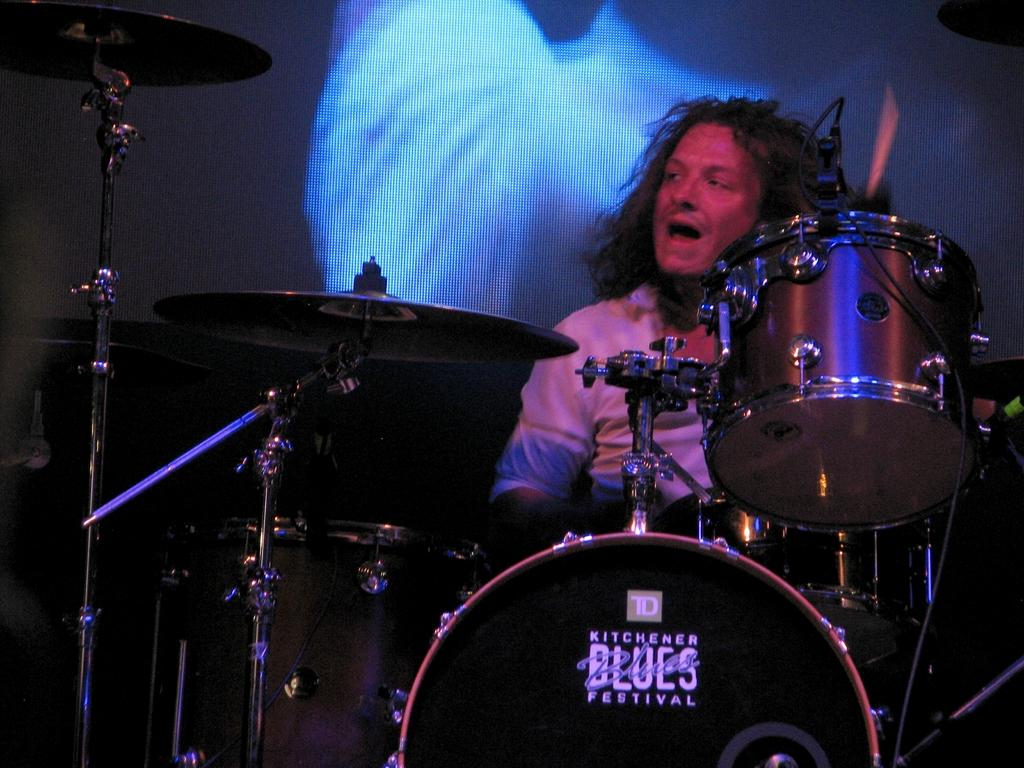Who or what is the main subject in the image? There is a person in the image. What else can be seen in the image besides the person? There are musical instruments and other objects in the image. Can you describe the background of the image? There is a screen visible in the background of the image. What type of owl can be seen sitting on the person's shoulder in the image? There is no owl present in the image; it only features a person, musical instruments, and other objects. 